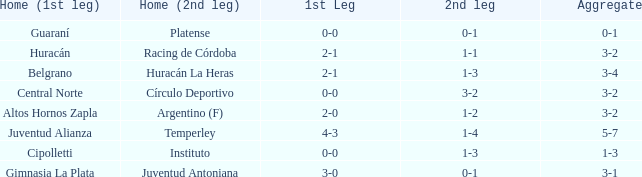Who took part at home in the 2nd leg, having a score of 1-2? Argentino (F). 